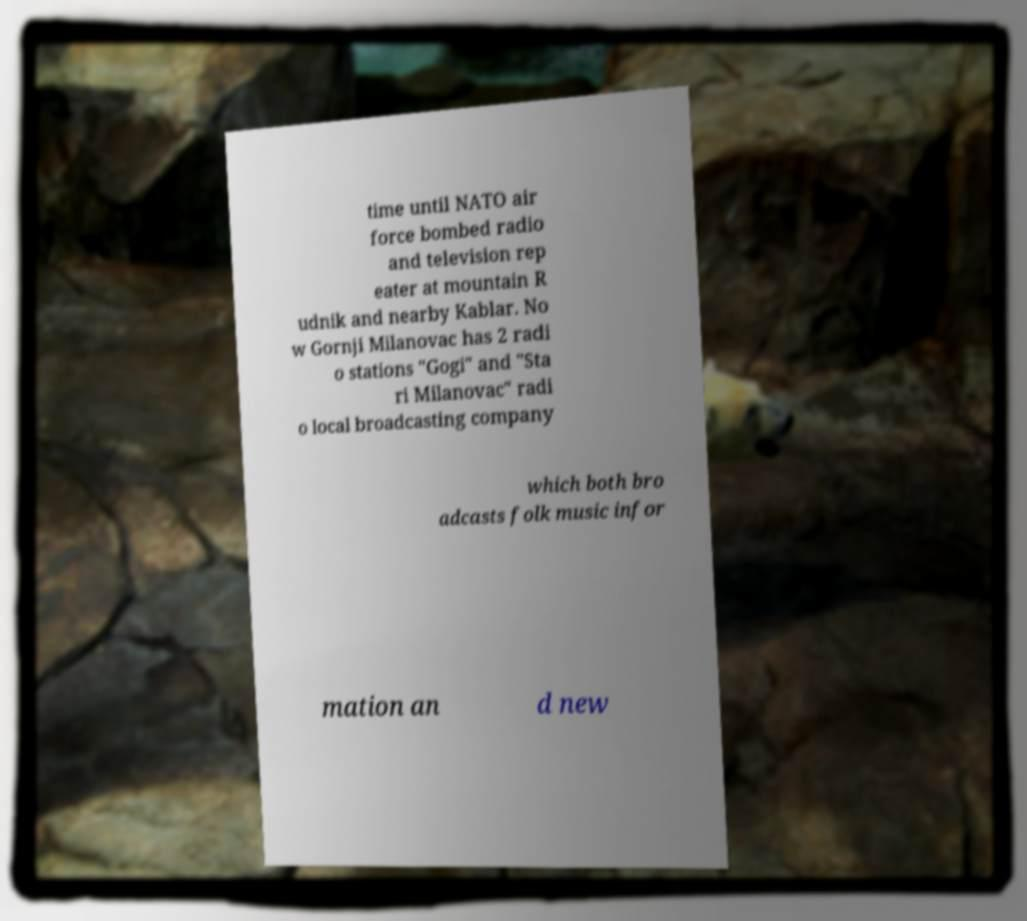What messages or text are displayed in this image? I need them in a readable, typed format. time until NATO air force bombed radio and television rep eater at mountain R udnik and nearby Kablar. No w Gornji Milanovac has 2 radi o stations "Gogi" and "Sta ri Milanovac" radi o local broadcasting company which both bro adcasts folk music infor mation an d new 